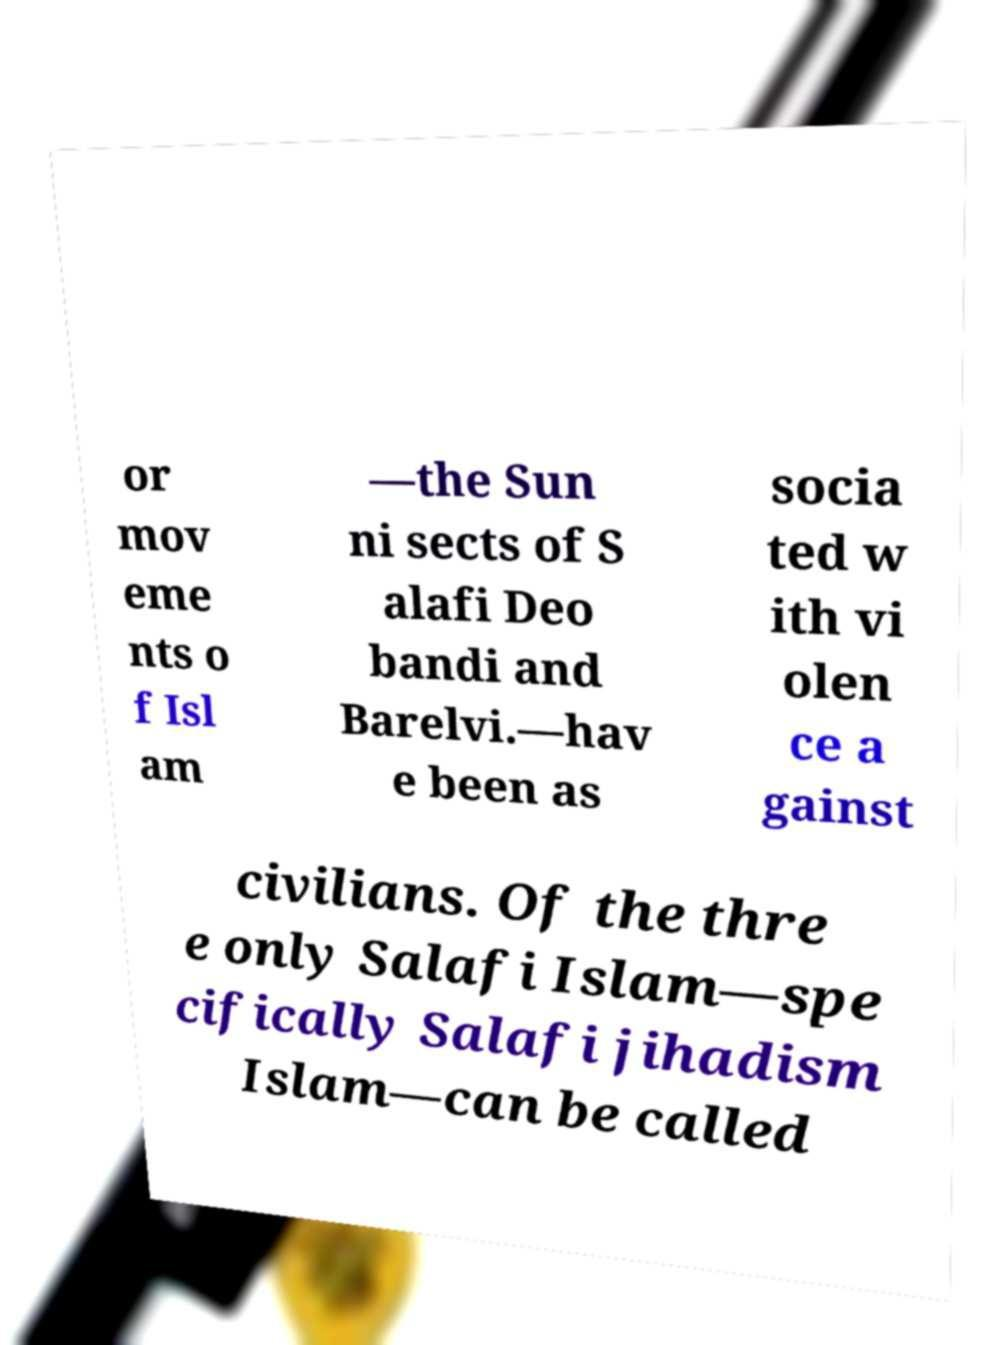Can you read and provide the text displayed in the image?This photo seems to have some interesting text. Can you extract and type it out for me? or mov eme nts o f Isl am —the Sun ni sects of S alafi Deo bandi and Barelvi.—hav e been as socia ted w ith vi olen ce a gainst civilians. Of the thre e only Salafi Islam—spe cifically Salafi jihadism Islam—can be called 